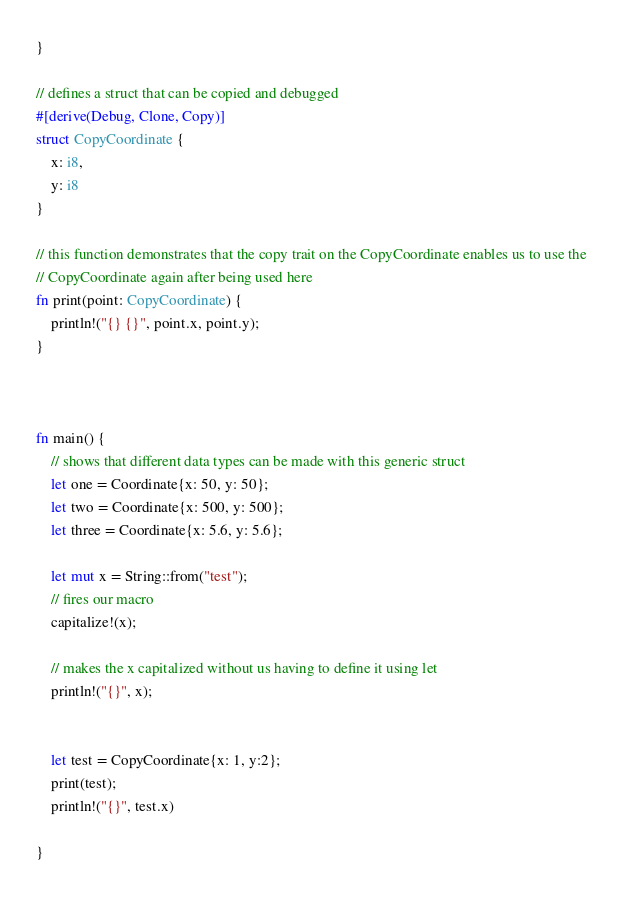Convert code to text. <code><loc_0><loc_0><loc_500><loc_500><_Rust_>}

// defines a struct that can be copied and debugged
#[derive(Debug, Clone, Copy)]
struct CopyCoordinate {
    x: i8,
    y: i8
}

// this function demonstrates that the copy trait on the CopyCoordinate enables us to use the
// CopyCoordinate again after being used here
fn print(point: CopyCoordinate) {
    println!("{} {}", point.x, point.y);
}



fn main() {
    // shows that different data types can be made with this generic struct
    let one = Coordinate{x: 50, y: 50};
    let two = Coordinate{x: 500, y: 500};
    let three = Coordinate{x: 5.6, y: 5.6};

    let mut x = String::from("test");
    // fires our macro
    capitalize!(x);

    // makes the x capitalized without us having to define it using let
    println!("{}", x);


    let test = CopyCoordinate{x: 1, y:2};
    print(test);
    println!("{}", test.x)

}
</code> 